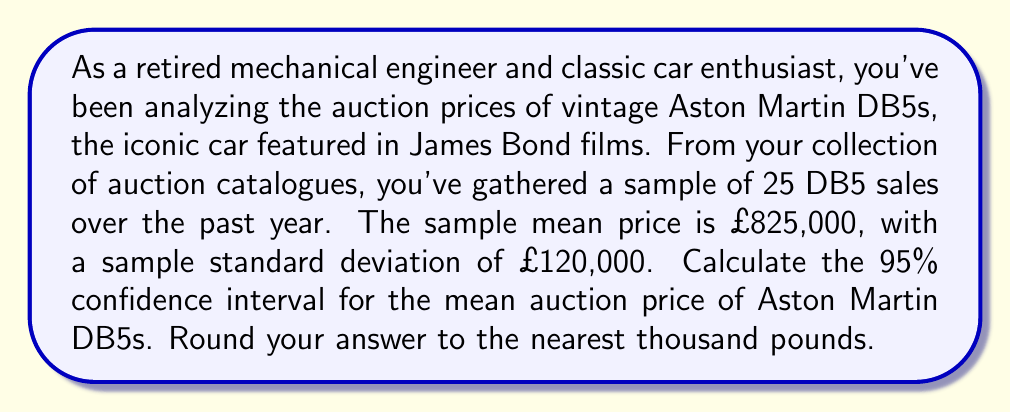Can you solve this math problem? To calculate the confidence interval for the mean, we'll use the formula:

$$ \text{CI} = \bar{x} \pm t_{\alpha/2} \cdot \frac{s}{\sqrt{n}} $$

Where:
- $\bar{x}$ is the sample mean (£825,000)
- $s$ is the sample standard deviation (£120,000)
- $n$ is the sample size (25)
- $t_{\alpha/2}$ is the t-value for a 95% confidence interval with 24 degrees of freedom (n-1)

Steps:
1. Find $t_{\alpha/2}$: For a 95% CI with 24 df, $t_{\alpha/2} = 2.064$

2. Calculate the standard error of the mean:
   $$ SE = \frac{s}{\sqrt{n}} = \frac{120,000}{\sqrt{25}} = 24,000 $$

3. Calculate the margin of error:
   $$ ME = t_{\alpha/2} \cdot SE = 2.064 \cdot 24,000 = 49,536 $$

4. Calculate the confidence interval:
   $$ \text{CI} = 825,000 \pm 49,536 $$
   $$ \text{Lower bound} = 825,000 - 49,536 = 775,464 $$
   $$ \text{Upper bound} = 825,000 + 49,536 = 874,536 $$

5. Round to the nearest thousand pounds:
   $$ \text{CI} = (775,000, 875,000) $$
Answer: The 95% confidence interval for the mean auction price of Aston Martin DB5s is (£775,000, £875,000). 